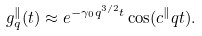Convert formula to latex. <formula><loc_0><loc_0><loc_500><loc_500>g _ { q } ^ { \| } ( t ) \approx e ^ { - \gamma _ { 0 } q ^ { 3 / 2 } t } \cos ( c ^ { \| } q t ) .</formula> 